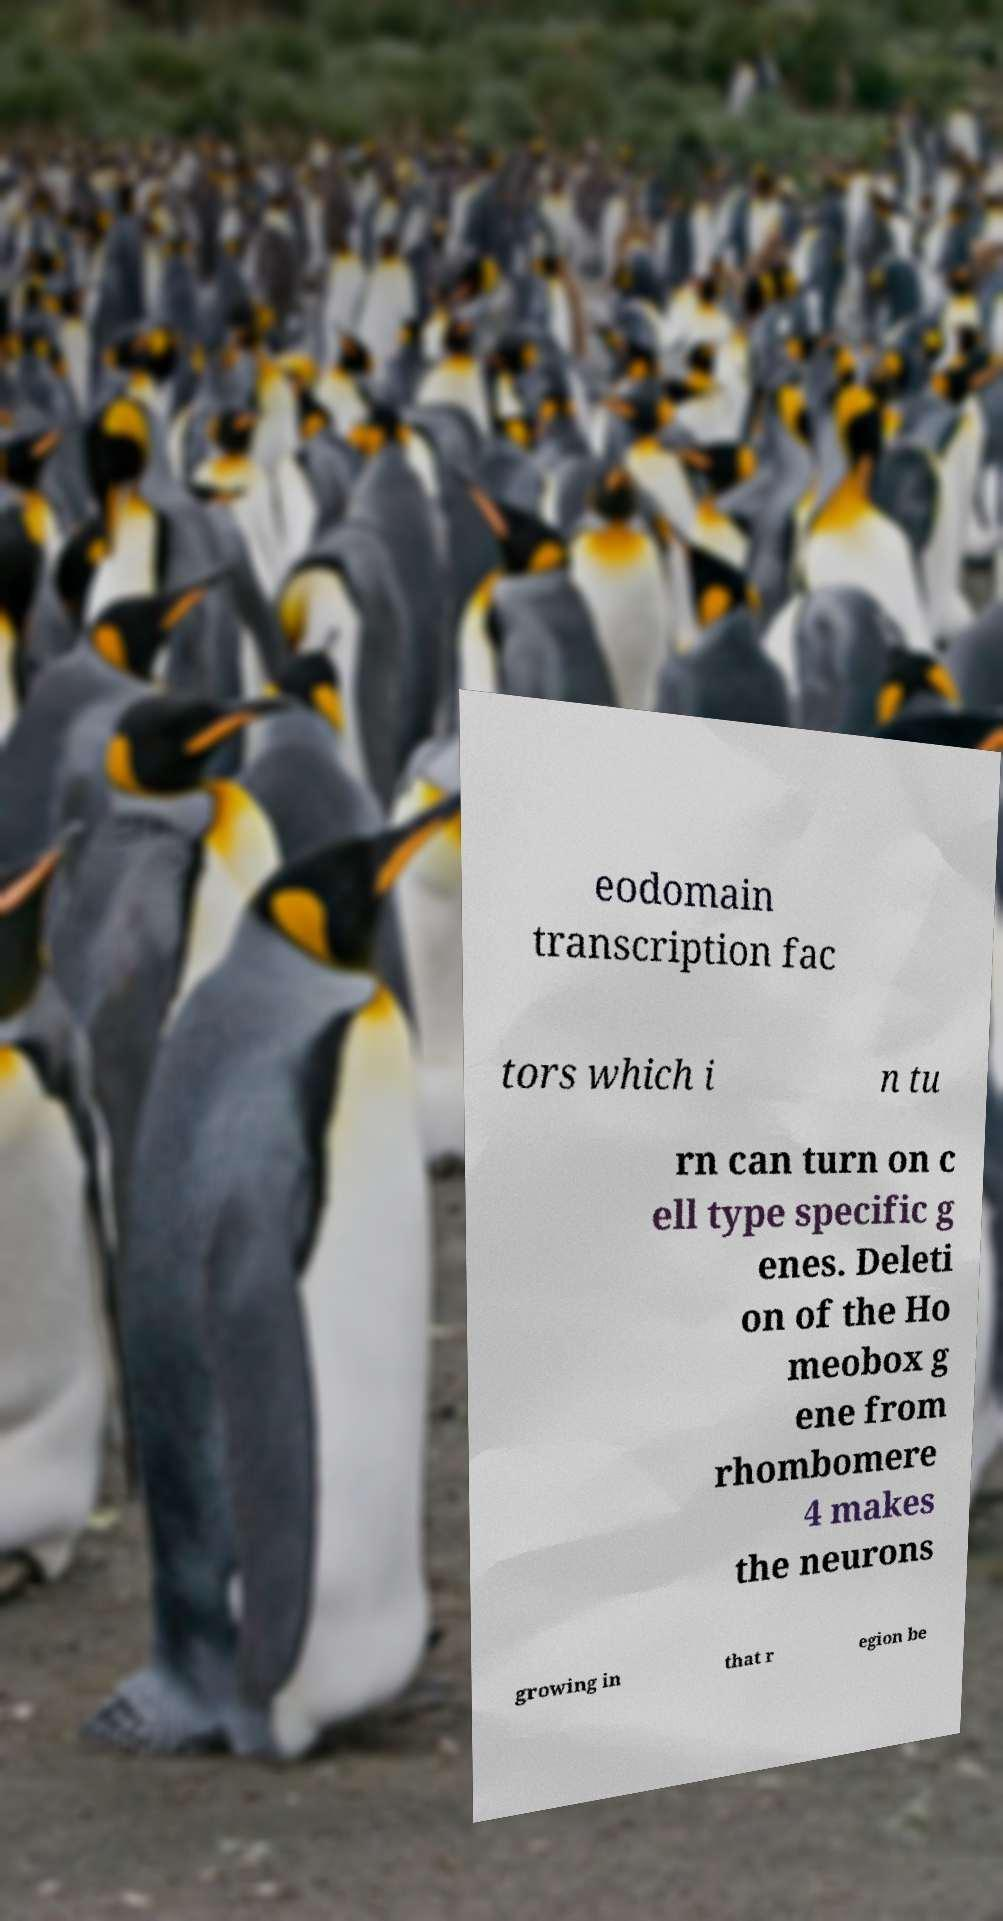Can you read and provide the text displayed in the image?This photo seems to have some interesting text. Can you extract and type it out for me? eodomain transcription fac tors which i n tu rn can turn on c ell type specific g enes. Deleti on of the Ho meobox g ene from rhombomere 4 makes the neurons growing in that r egion be 